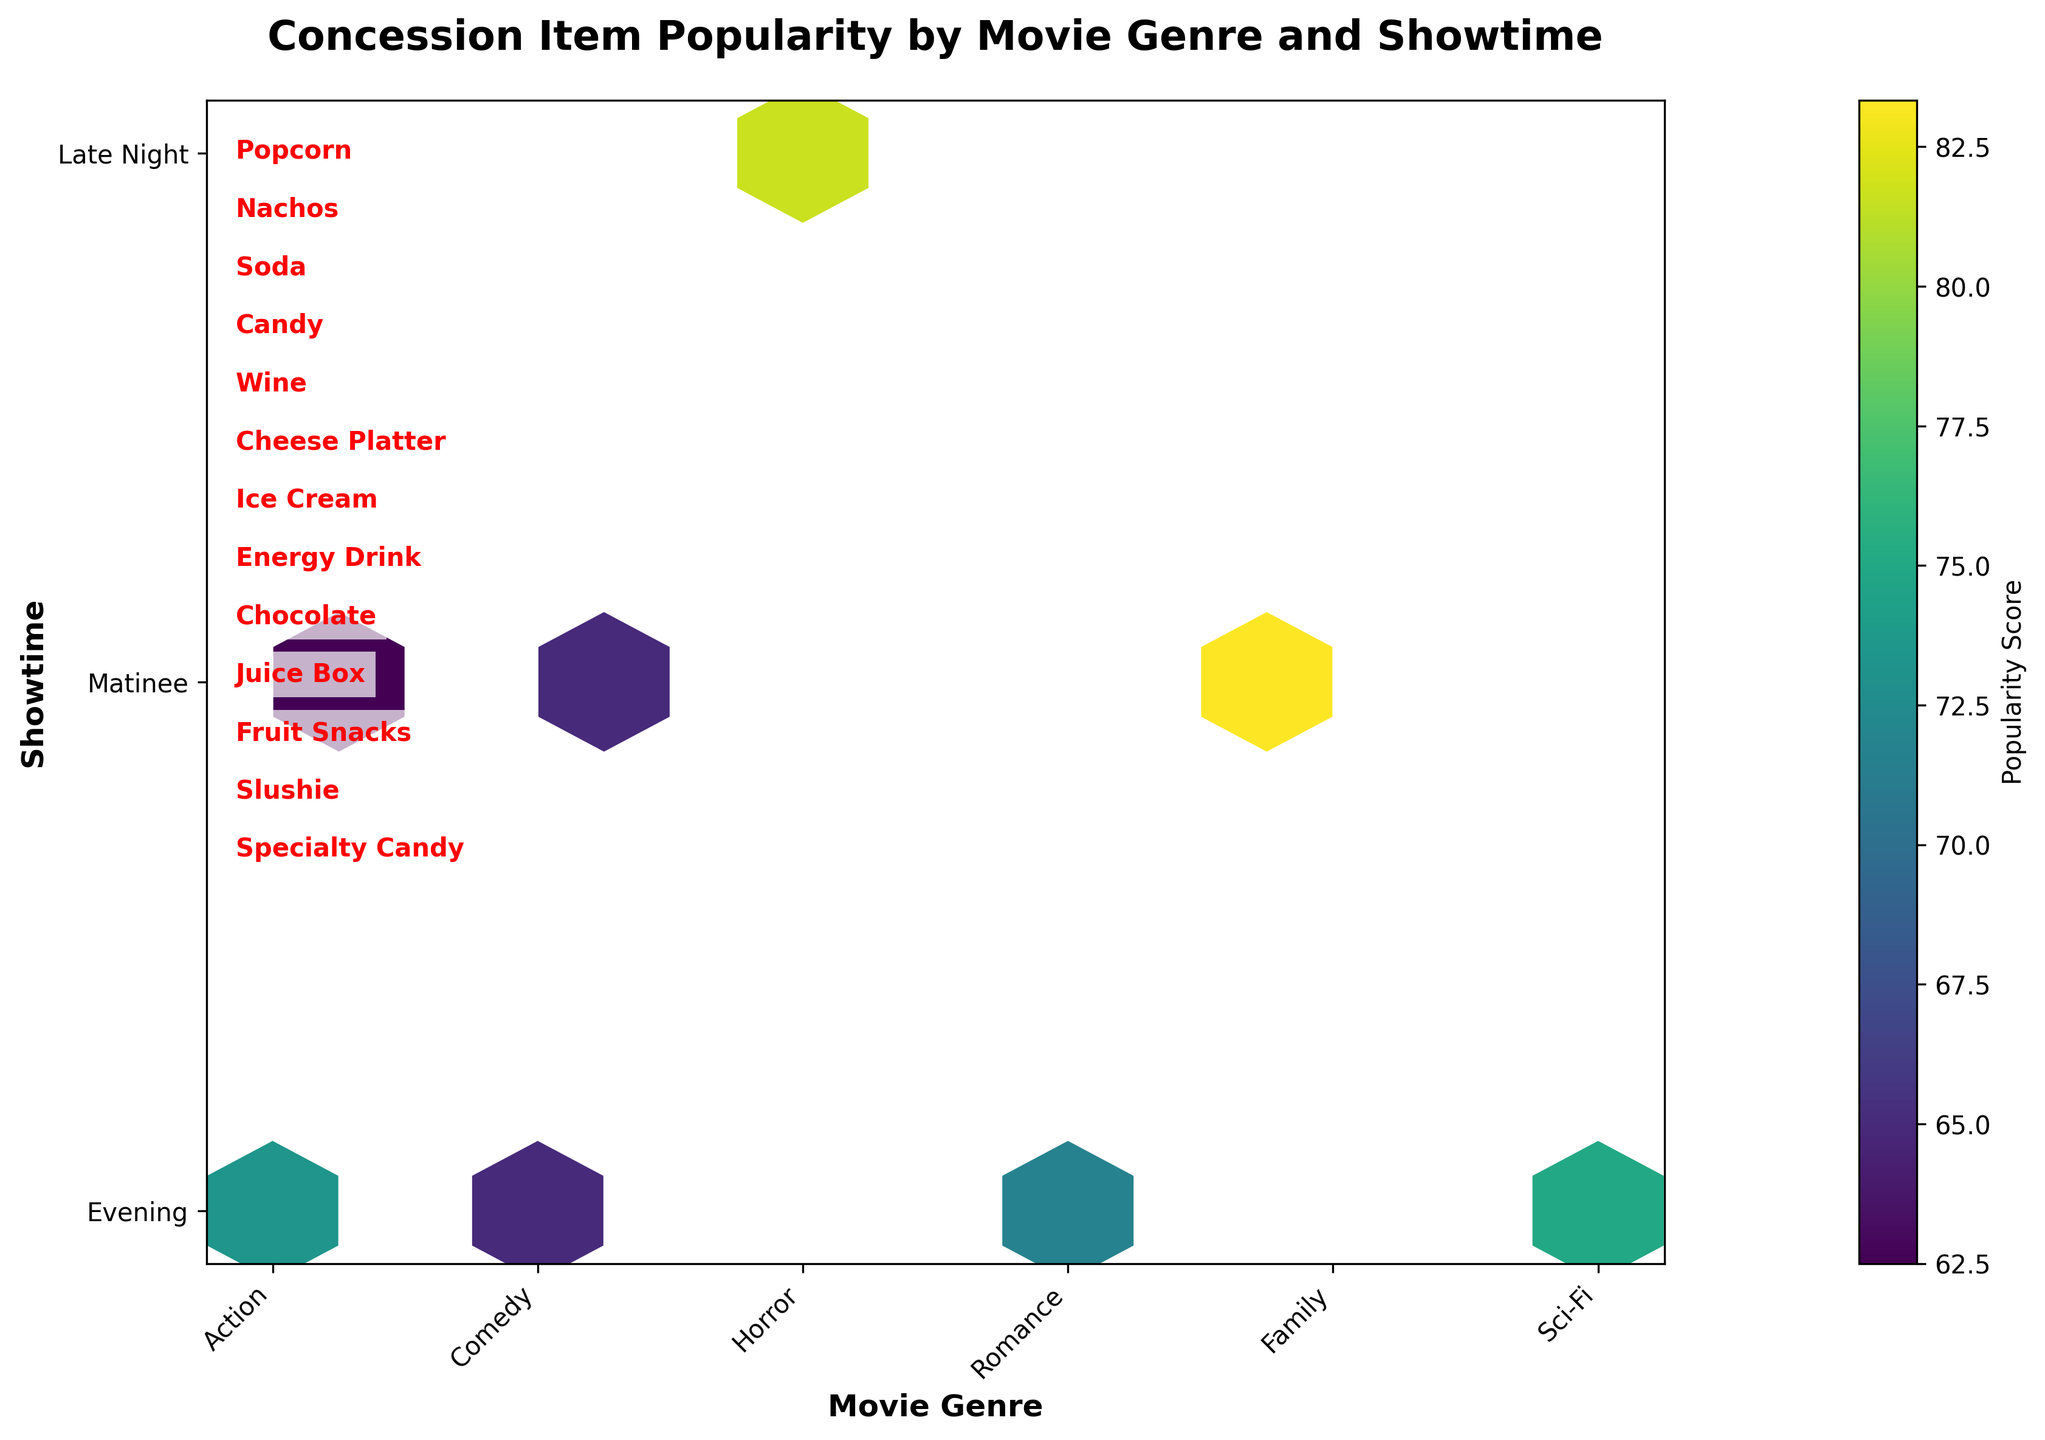What is the title of the hexbin plot? The title of the hexbin plot is written at the top of the figure and clearly states what the plot represents.
Answer: Concession Item Popularity by Movie Genre and Showtime Which movie genre corresponds to the highest popularity score in the plot? To find the movie genre with the highest popularity score, look for the brightest hexagon in the plot and trace back to its corresponding movie genre on the x-axis.
Answer: Family What is the showtime with the highest popularity score in the plot? To determine the showtime with the highest popularity score, find the brightest hexagon and trace it back to its corresponding showtime on the y-axis.
Answer: Matinee Which movie genre has the most diverse concession item popularity based on the color range in the hexbin? The diversity can be inferred by the range of colors in the hexagons for a specific movie genre. A wider range of colors indicates more diverse popularity scores.
Answer: Action What is the average popularity score for the 'Evening' showtime across all movie genres? First, identify all hexagons corresponding to the 'Evening' showtime, sum up their popularity scores, and then divide by the number of hexagons.
Answer: (85+60+75+80+65+50+85+70+60+88+72+65)/12 = 70.5 Which hexagon represents the combination of 'Sci-Fi' genre and 'Evening' showtime? Locate the intersection of 'Sci-Fi' genre on the x-axis and 'Evening' showtime on the y-axis, then identify the hexagon at that point.
Answer: The hexagon at (Sci-Fi, Evening) Is the popularity of 'Popcorn' highest in 'Horror' compared to other genres? Compare the color intensity of the hexagons where 'Popcorn' is sold in different genres, focusing on the 'Horror' genre.
Answer: Yes Between 'Popcorn' and 'Wine', which concession item is more popular in 'Romance' movies? Compare the hexagons for 'Romance' genre showtimes where 'Popcorn' and 'Wine' are sold; the brighter hexagon denotes higher popularity.
Answer: Wine How does the 'Late Night' showtime's popularity score for 'Horror' compare to 'Family' matinee? Compare the brightness of the hexagons for 'Horror' at 'Late Night' and 'Family' at 'Matinee'.
Answer: Family Matinee is higher What does the color bar on the right side of the hexbin plot represent? The color bar indicates the range of popularity scores represented by different colors in the hexagons, ranging from low to high popularity.
Answer: Popularity Score 